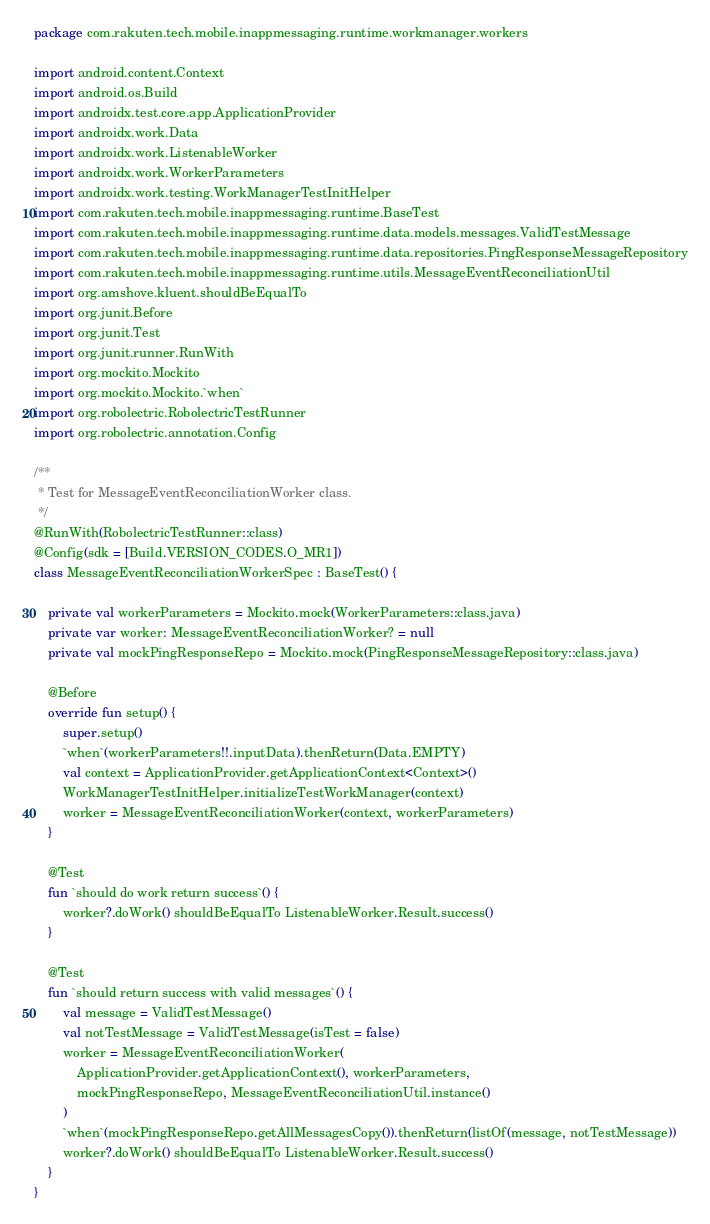Convert code to text. <code><loc_0><loc_0><loc_500><loc_500><_Kotlin_>package com.rakuten.tech.mobile.inappmessaging.runtime.workmanager.workers

import android.content.Context
import android.os.Build
import androidx.test.core.app.ApplicationProvider
import androidx.work.Data
import androidx.work.ListenableWorker
import androidx.work.WorkerParameters
import androidx.work.testing.WorkManagerTestInitHelper
import com.rakuten.tech.mobile.inappmessaging.runtime.BaseTest
import com.rakuten.tech.mobile.inappmessaging.runtime.data.models.messages.ValidTestMessage
import com.rakuten.tech.mobile.inappmessaging.runtime.data.repositories.PingResponseMessageRepository
import com.rakuten.tech.mobile.inappmessaging.runtime.utils.MessageEventReconciliationUtil
import org.amshove.kluent.shouldBeEqualTo
import org.junit.Before
import org.junit.Test
import org.junit.runner.RunWith
import org.mockito.Mockito
import org.mockito.Mockito.`when`
import org.robolectric.RobolectricTestRunner
import org.robolectric.annotation.Config

/**
 * Test for MessageEventReconciliationWorker class.
 */
@RunWith(RobolectricTestRunner::class)
@Config(sdk = [Build.VERSION_CODES.O_MR1])
class MessageEventReconciliationWorkerSpec : BaseTest() {

    private val workerParameters = Mockito.mock(WorkerParameters::class.java)
    private var worker: MessageEventReconciliationWorker? = null
    private val mockPingResponseRepo = Mockito.mock(PingResponseMessageRepository::class.java)

    @Before
    override fun setup() {
        super.setup()
        `when`(workerParameters!!.inputData).thenReturn(Data.EMPTY)
        val context = ApplicationProvider.getApplicationContext<Context>()
        WorkManagerTestInitHelper.initializeTestWorkManager(context)
        worker = MessageEventReconciliationWorker(context, workerParameters)
    }

    @Test
    fun `should do work return success`() {
        worker?.doWork() shouldBeEqualTo ListenableWorker.Result.success()
    }

    @Test
    fun `should return success with valid messages`() {
        val message = ValidTestMessage()
        val notTestMessage = ValidTestMessage(isTest = false)
        worker = MessageEventReconciliationWorker(
            ApplicationProvider.getApplicationContext(), workerParameters,
            mockPingResponseRepo, MessageEventReconciliationUtil.instance()
        )
        `when`(mockPingResponseRepo.getAllMessagesCopy()).thenReturn(listOf(message, notTestMessage))
        worker?.doWork() shouldBeEqualTo ListenableWorker.Result.success()
    }
}
</code> 